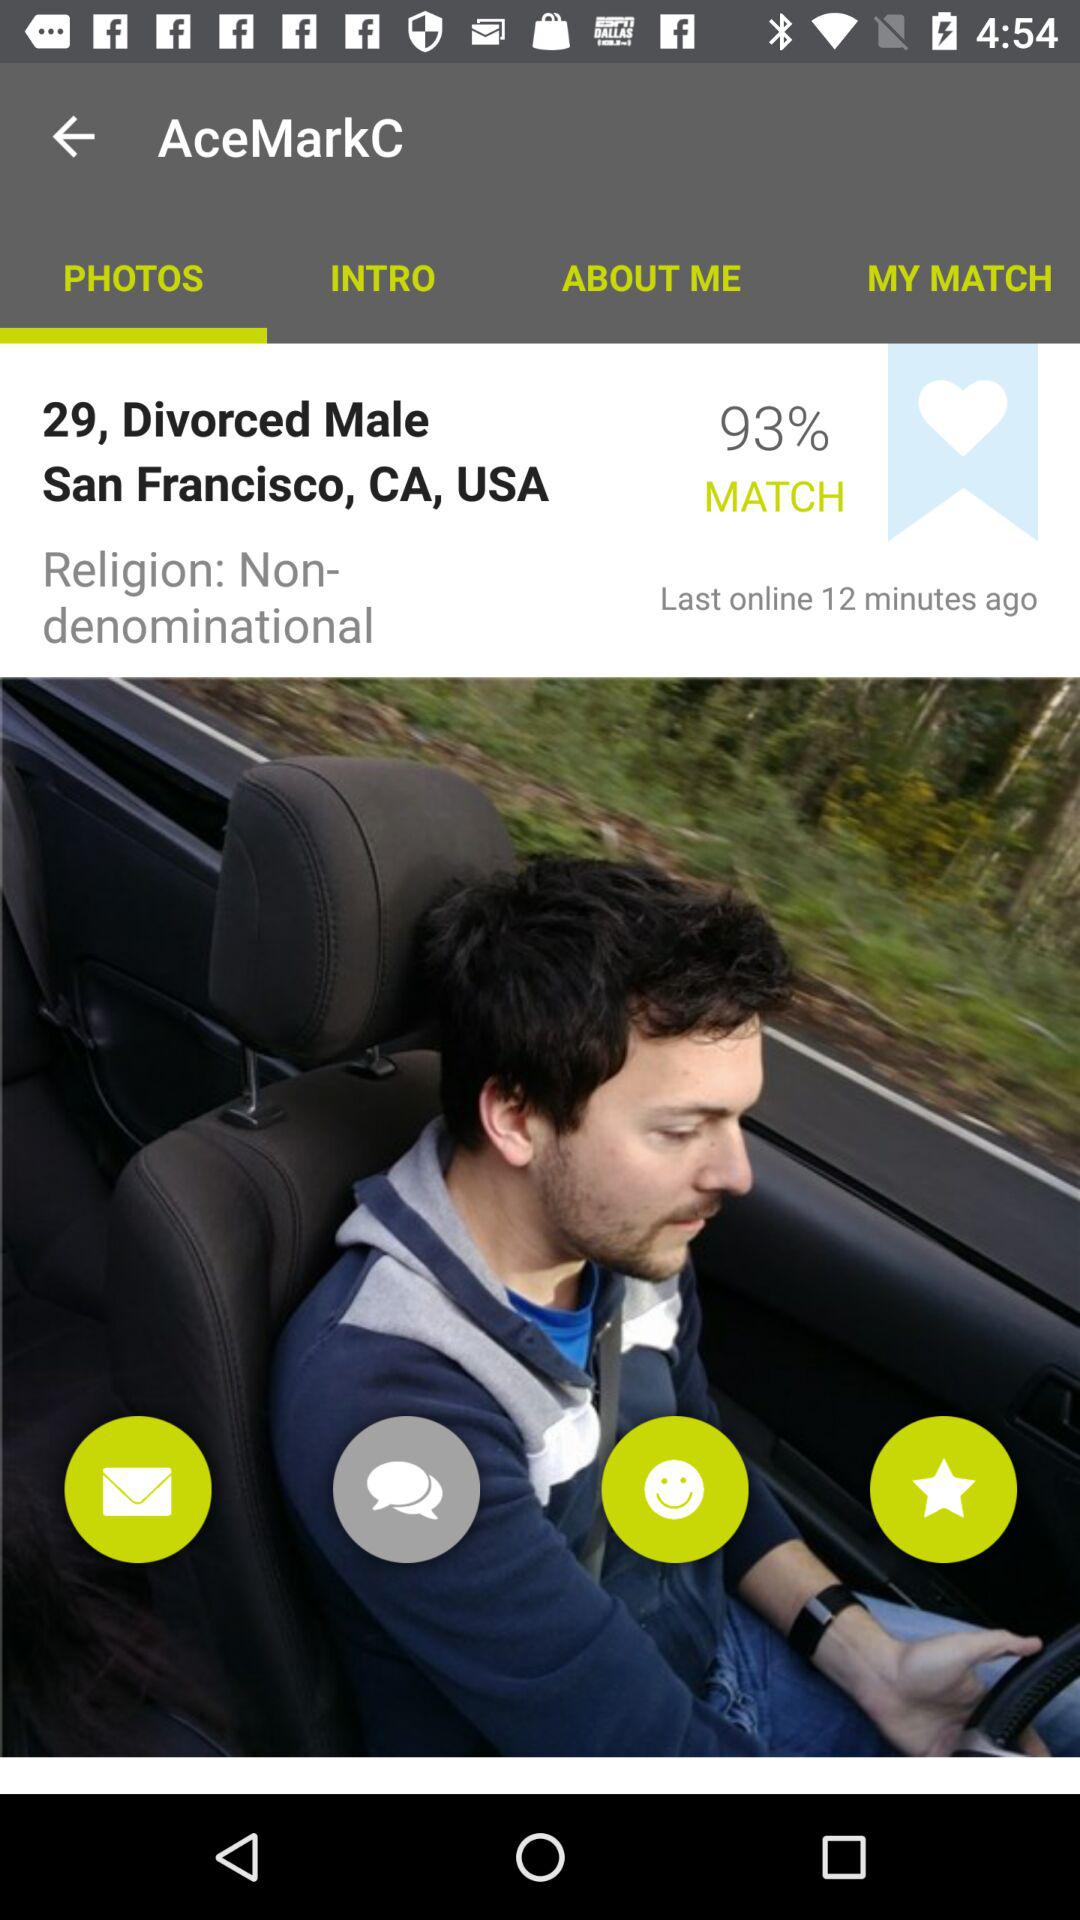What is the marital status given? The marital status is divorced. 